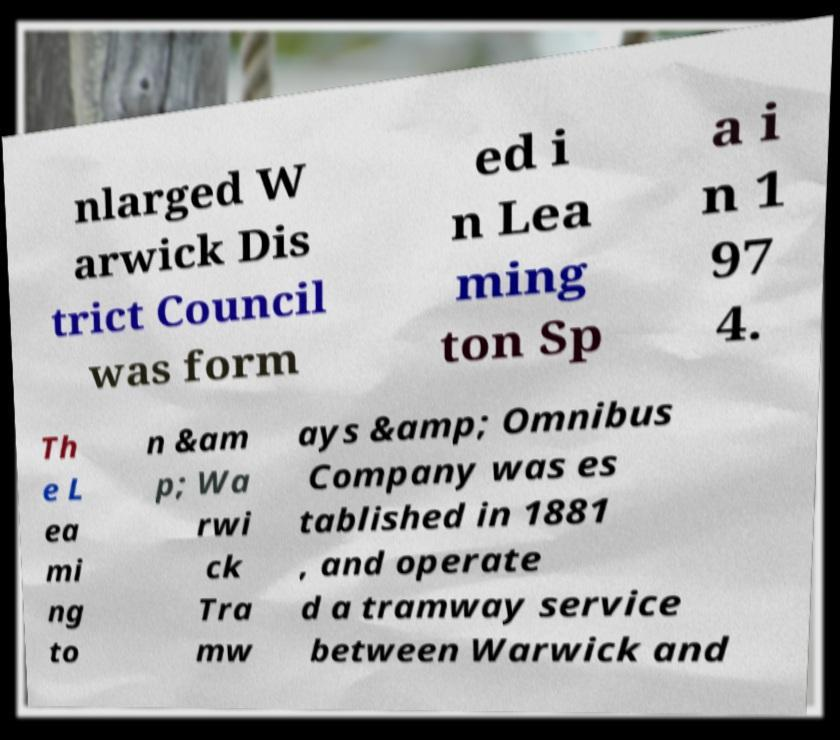Please read and relay the text visible in this image. What does it say? nlarged W arwick Dis trict Council was form ed i n Lea ming ton Sp a i n 1 97 4. Th e L ea mi ng to n &am p; Wa rwi ck Tra mw ays &amp; Omnibus Company was es tablished in 1881 , and operate d a tramway service between Warwick and 